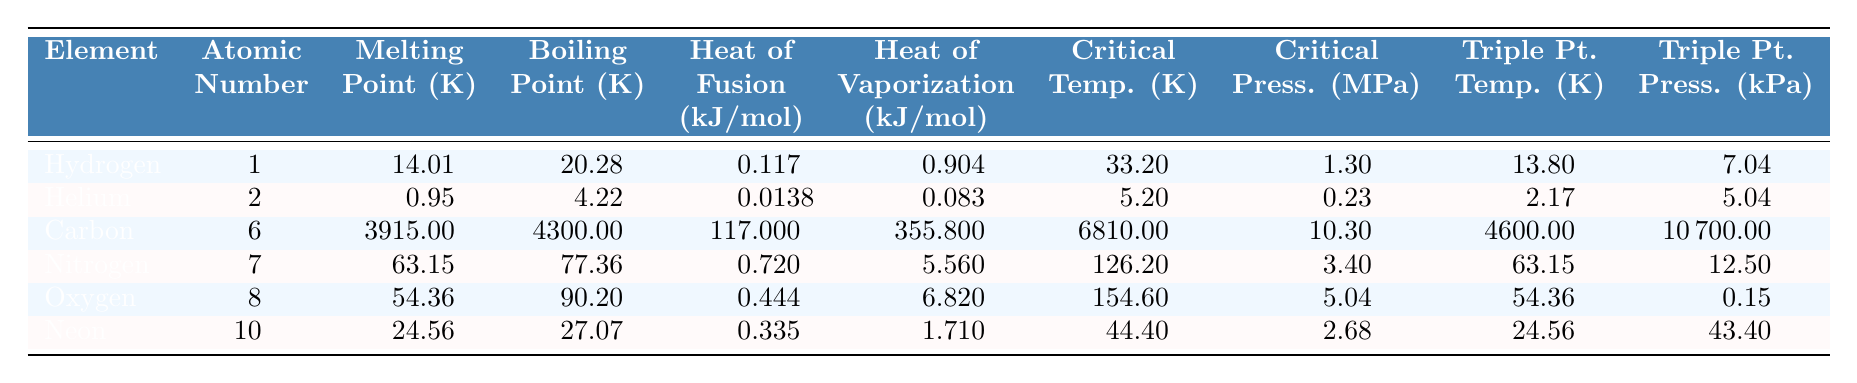What's the melting point of Nitrogen? According to the table, the melting point of Nitrogen is listed as 63.15 K.
Answer: 63.15 K What is the atomic number of Oxygen? The table indicates that the atomic number of Oxygen is 8.
Answer: 8 Which element has the highest boiling point? By examining the boiling points in the table, Carbon has the highest boiling point at 4300 K.
Answer: Carbon What is the heat of fusion for Helium? The table provides the heat of fusion for Helium as 0.0138 kJ/mol.
Answer: 0.0138 kJ/mol Which element has the lowest critical temperature? Helium has the lowest critical temperature at 5.2 K as shown in the table.
Answer: Helium Calculate the difference between the boiling point of Carbon and the boiling point of Oxygen. The boiling point of Carbon is 4300 K and that of Oxygen is 90.2 K. The difference is 4300 K - 90.2 K = 4209.8 K.
Answer: 4209.8 K Is the heat of vaporization for Neon greater than that for Nitrogen? By comparing the values from the table, Neon has a heat of vaporization of 1.71 kJ/mol and Nitrogen has 5.56 kJ/mol, thus Neon’s heat of vaporization is less.
Answer: No What is the average melting point of the elements listed? The melting points of the elements are: Hydrogen (14.01 K), Helium (0.95 K), Carbon (3915 K), Nitrogen (63.15 K), Oxygen (54.36 K), Neon (24.56 K). Adding these gives a total of 4072.03 K, and dividing by 6 gives an average melting point of approximately 678.67 K.
Answer: 678.67 K Which element has a triple point temperature equal to its melting point? From the table, both Nitrogen and Oxygen have their triple point temperatures at 63.15 K and 54.36 K, respectively, which are respectively equal to their melting points.
Answer: Nitrogen and Oxygen If you modify the heat of vaporization of Hydrogen by a factor of 2, what would the new value be? The heat of vaporization of Hydrogen is 0.904 kJ/mol; doubling it gives 0.904 kJ/mol * 2 = 1.808 kJ/mol.
Answer: 1.808 kJ/mol 